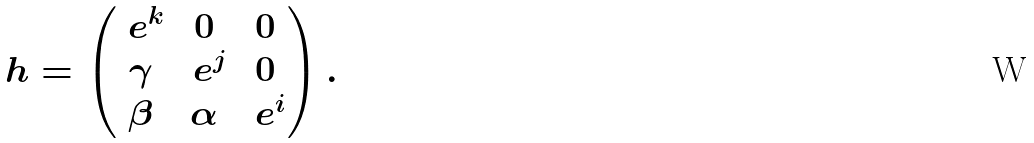<formula> <loc_0><loc_0><loc_500><loc_500>h = \begin{pmatrix} \ e ^ { k } & 0 & 0 \\ \gamma & \ e ^ { j } & 0 \\ \beta & \alpha & \ e ^ { i } \end{pmatrix} .</formula> 